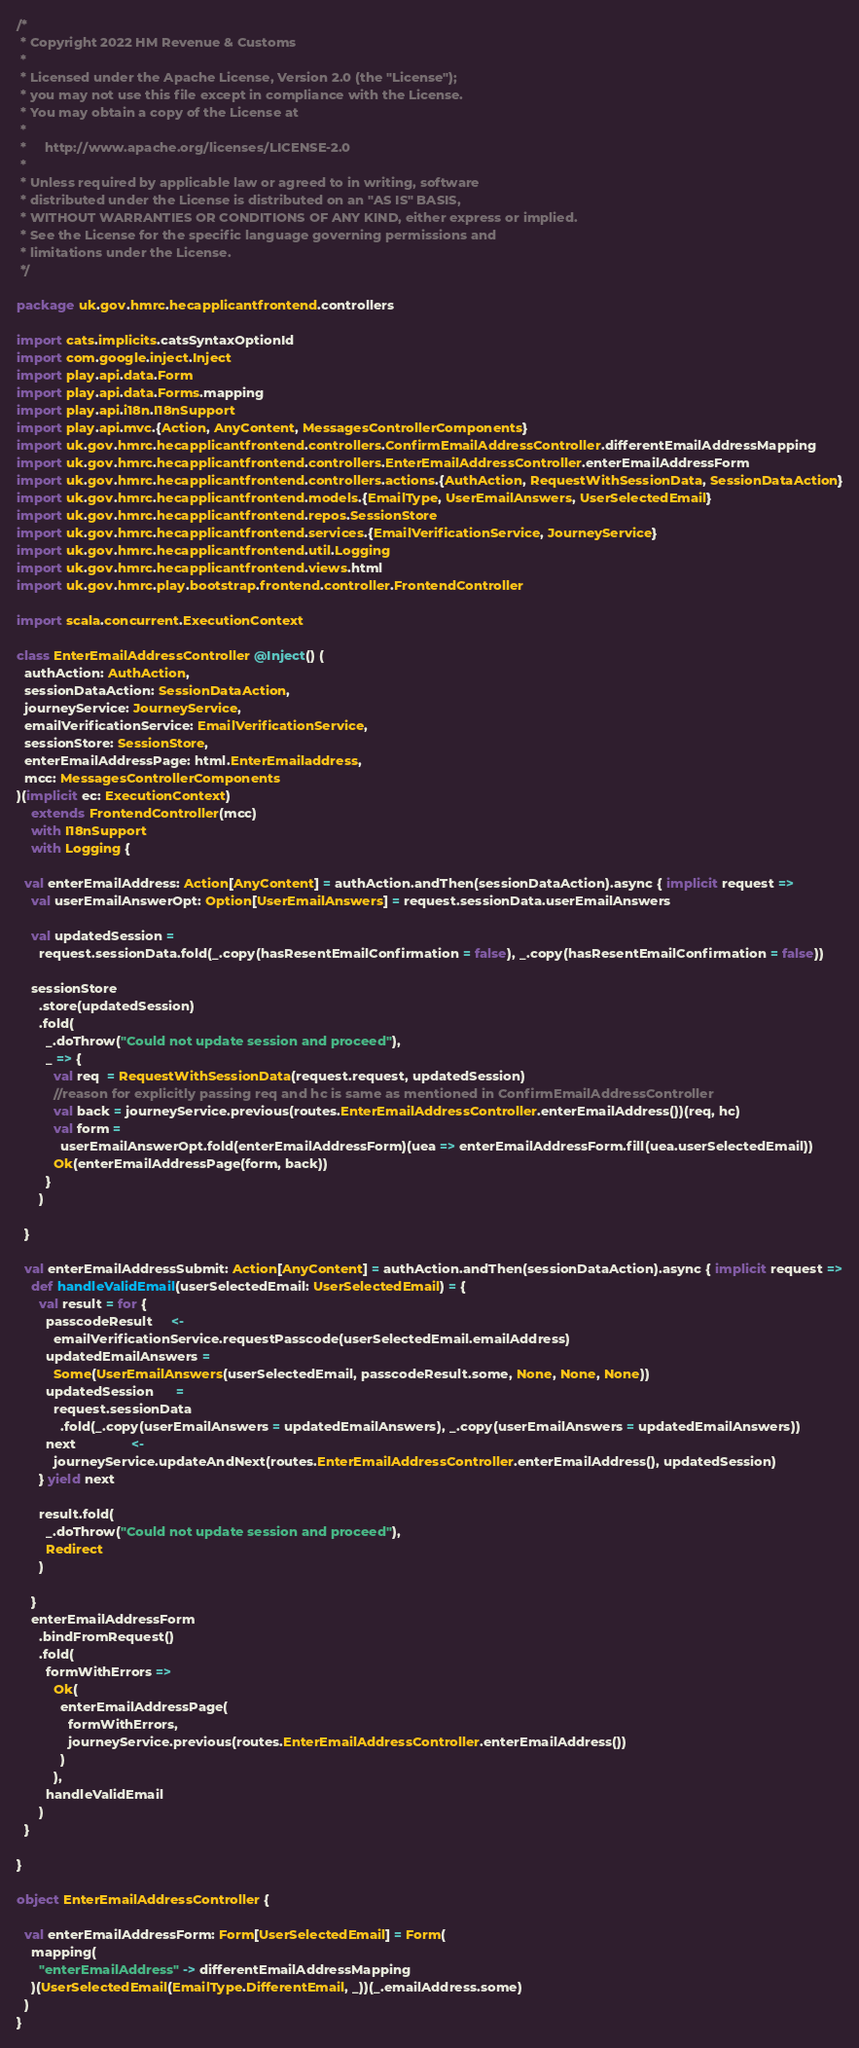<code> <loc_0><loc_0><loc_500><loc_500><_Scala_>/*
 * Copyright 2022 HM Revenue & Customs
 *
 * Licensed under the Apache License, Version 2.0 (the "License");
 * you may not use this file except in compliance with the License.
 * You may obtain a copy of the License at
 *
 *     http://www.apache.org/licenses/LICENSE-2.0
 *
 * Unless required by applicable law or agreed to in writing, software
 * distributed under the License is distributed on an "AS IS" BASIS,
 * WITHOUT WARRANTIES OR CONDITIONS OF ANY KIND, either express or implied.
 * See the License for the specific language governing permissions and
 * limitations under the License.
 */

package uk.gov.hmrc.hecapplicantfrontend.controllers

import cats.implicits.catsSyntaxOptionId
import com.google.inject.Inject
import play.api.data.Form
import play.api.data.Forms.mapping
import play.api.i18n.I18nSupport
import play.api.mvc.{Action, AnyContent, MessagesControllerComponents}
import uk.gov.hmrc.hecapplicantfrontend.controllers.ConfirmEmailAddressController.differentEmailAddressMapping
import uk.gov.hmrc.hecapplicantfrontend.controllers.EnterEmailAddressController.enterEmailAddressForm
import uk.gov.hmrc.hecapplicantfrontend.controllers.actions.{AuthAction, RequestWithSessionData, SessionDataAction}
import uk.gov.hmrc.hecapplicantfrontend.models.{EmailType, UserEmailAnswers, UserSelectedEmail}
import uk.gov.hmrc.hecapplicantfrontend.repos.SessionStore
import uk.gov.hmrc.hecapplicantfrontend.services.{EmailVerificationService, JourneyService}
import uk.gov.hmrc.hecapplicantfrontend.util.Logging
import uk.gov.hmrc.hecapplicantfrontend.views.html
import uk.gov.hmrc.play.bootstrap.frontend.controller.FrontendController

import scala.concurrent.ExecutionContext

class EnterEmailAddressController @Inject() (
  authAction: AuthAction,
  sessionDataAction: SessionDataAction,
  journeyService: JourneyService,
  emailVerificationService: EmailVerificationService,
  sessionStore: SessionStore,
  enterEmailAddressPage: html.EnterEmailaddress,
  mcc: MessagesControllerComponents
)(implicit ec: ExecutionContext)
    extends FrontendController(mcc)
    with I18nSupport
    with Logging {

  val enterEmailAddress: Action[AnyContent] = authAction.andThen(sessionDataAction).async { implicit request =>
    val userEmailAnswerOpt: Option[UserEmailAnswers] = request.sessionData.userEmailAnswers

    val updatedSession =
      request.sessionData.fold(_.copy(hasResentEmailConfirmation = false), _.copy(hasResentEmailConfirmation = false))

    sessionStore
      .store(updatedSession)
      .fold(
        _.doThrow("Could not update session and proceed"),
        _ => {
          val req  = RequestWithSessionData(request.request, updatedSession)
          //reason for explicitly passing req and hc is same as mentioned in ConfirmEmailAddressController
          val back = journeyService.previous(routes.EnterEmailAddressController.enterEmailAddress())(req, hc)
          val form =
            userEmailAnswerOpt.fold(enterEmailAddressForm)(uea => enterEmailAddressForm.fill(uea.userSelectedEmail))
          Ok(enterEmailAddressPage(form, back))
        }
      )

  }

  val enterEmailAddressSubmit: Action[AnyContent] = authAction.andThen(sessionDataAction).async { implicit request =>
    def handleValidEmail(userSelectedEmail: UserSelectedEmail) = {
      val result = for {
        passcodeResult     <-
          emailVerificationService.requestPasscode(userSelectedEmail.emailAddress)
        updatedEmailAnswers =
          Some(UserEmailAnswers(userSelectedEmail, passcodeResult.some, None, None, None))
        updatedSession      =
          request.sessionData
            .fold(_.copy(userEmailAnswers = updatedEmailAnswers), _.copy(userEmailAnswers = updatedEmailAnswers))
        next               <-
          journeyService.updateAndNext(routes.EnterEmailAddressController.enterEmailAddress(), updatedSession)
      } yield next

      result.fold(
        _.doThrow("Could not update session and proceed"),
        Redirect
      )

    }
    enterEmailAddressForm
      .bindFromRequest()
      .fold(
        formWithErrors =>
          Ok(
            enterEmailAddressPage(
              formWithErrors,
              journeyService.previous(routes.EnterEmailAddressController.enterEmailAddress())
            )
          ),
        handleValidEmail
      )
  }

}

object EnterEmailAddressController {

  val enterEmailAddressForm: Form[UserSelectedEmail] = Form(
    mapping(
      "enterEmailAddress" -> differentEmailAddressMapping
    )(UserSelectedEmail(EmailType.DifferentEmail, _))(_.emailAddress.some)
  )
}
</code> 